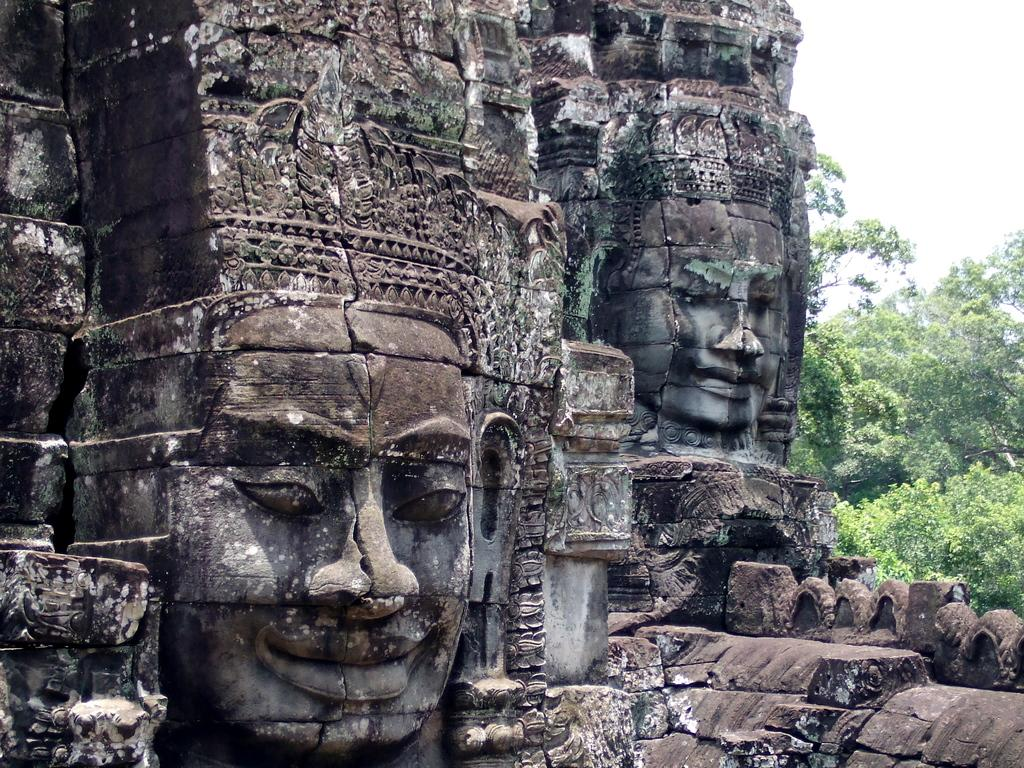What is the main subject of the image? There is a stone carving in the image. What can be seen in the background of the image? There are trees and the sky visible in the background of the image. Can you tell me how many buns the monkey is holding in the image? There is no monkey or buns present in the image; it features a stone carving and a background with trees and the sky. 